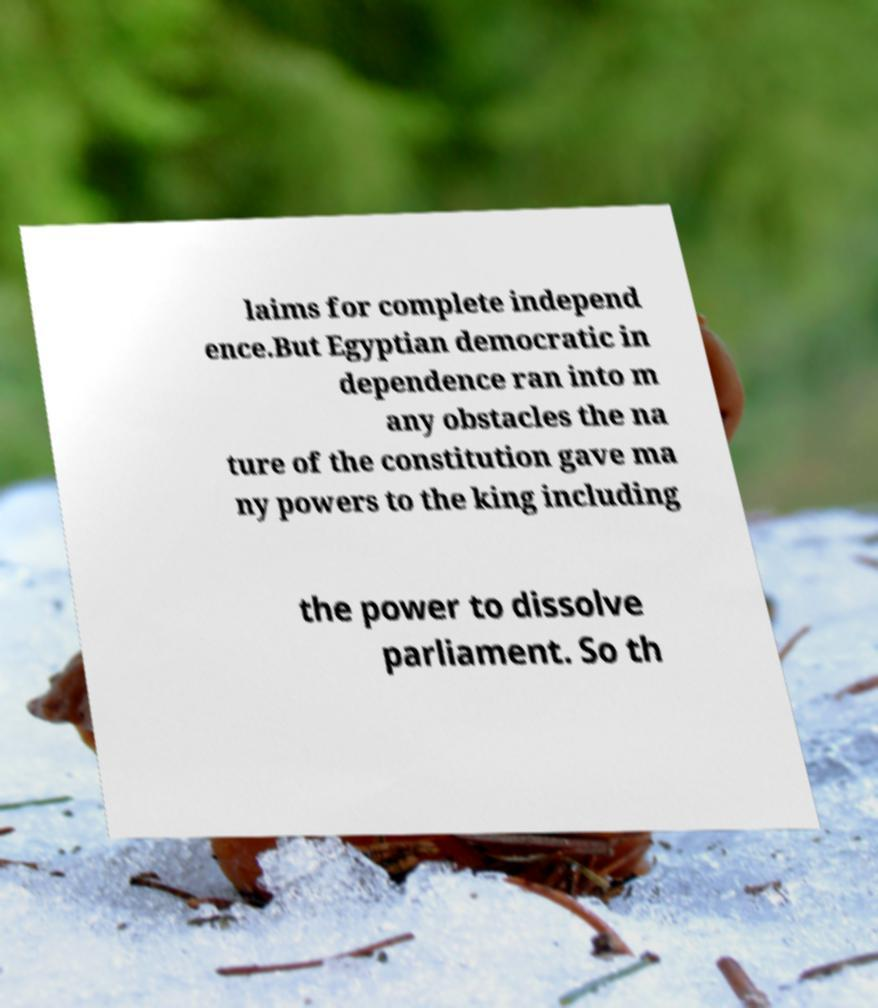Can you accurately transcribe the text from the provided image for me? laims for complete independ ence.But Egyptian democratic in dependence ran into m any obstacles the na ture of the constitution gave ma ny powers to the king including the power to dissolve parliament. So th 